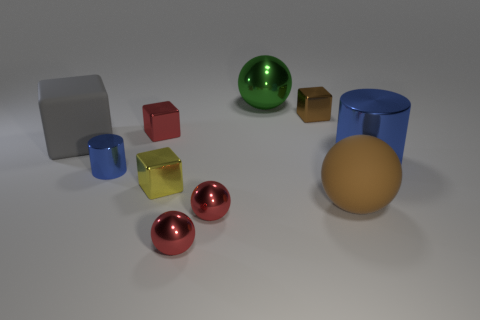Subtract all balls. How many objects are left? 6 Subtract all red cubes. Subtract all purple metallic balls. How many objects are left? 9 Add 4 brown balls. How many brown balls are left? 5 Add 2 tiny blue cylinders. How many tiny blue cylinders exist? 3 Subtract 0 blue balls. How many objects are left? 10 